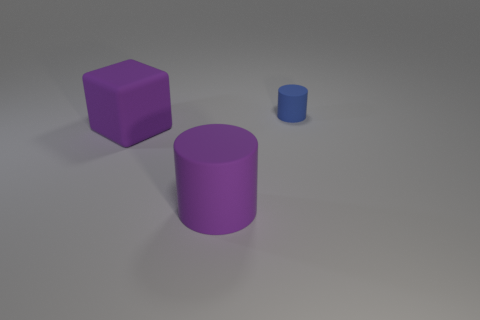Subtract 1 cubes. How many cubes are left? 0 Add 1 big purple rubber cubes. How many objects exist? 4 Subtract all cubes. How many objects are left? 2 Subtract all blue balls. How many purple cylinders are left? 1 Subtract all tiny green metal cylinders. Subtract all large purple things. How many objects are left? 1 Add 2 tiny blue matte objects. How many tiny blue matte objects are left? 3 Add 1 tiny blue cylinders. How many tiny blue cylinders exist? 2 Subtract 0 cyan spheres. How many objects are left? 3 Subtract all brown cylinders. Subtract all red cubes. How many cylinders are left? 2 